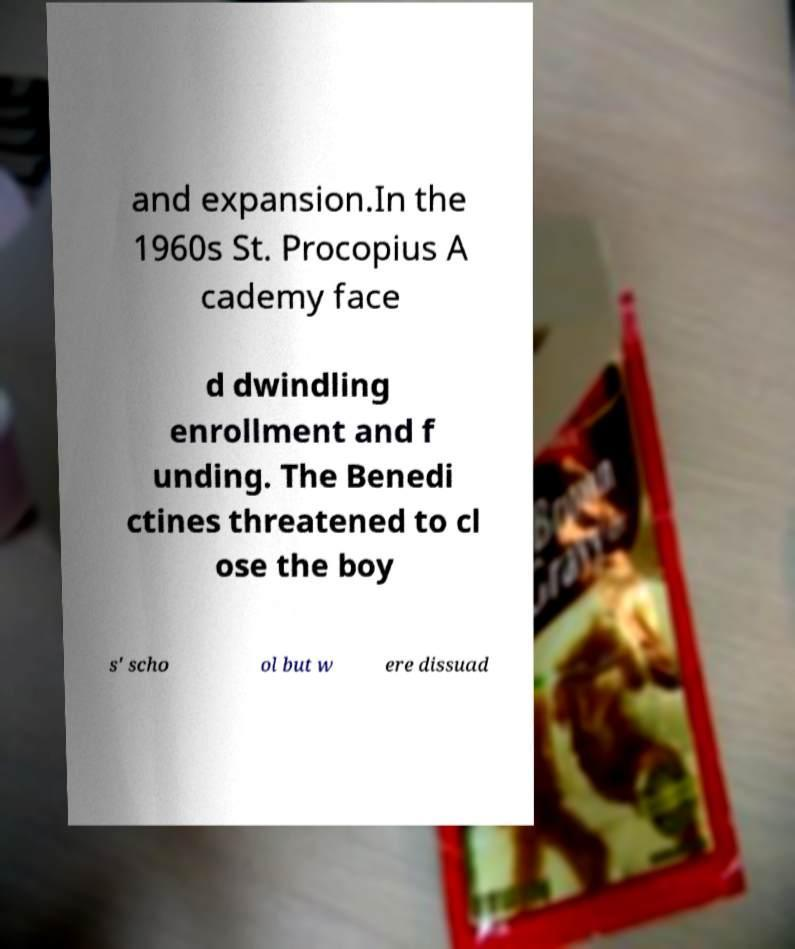There's text embedded in this image that I need extracted. Can you transcribe it verbatim? and expansion.In the 1960s St. Procopius A cademy face d dwindling enrollment and f unding. The Benedi ctines threatened to cl ose the boy s' scho ol but w ere dissuad 